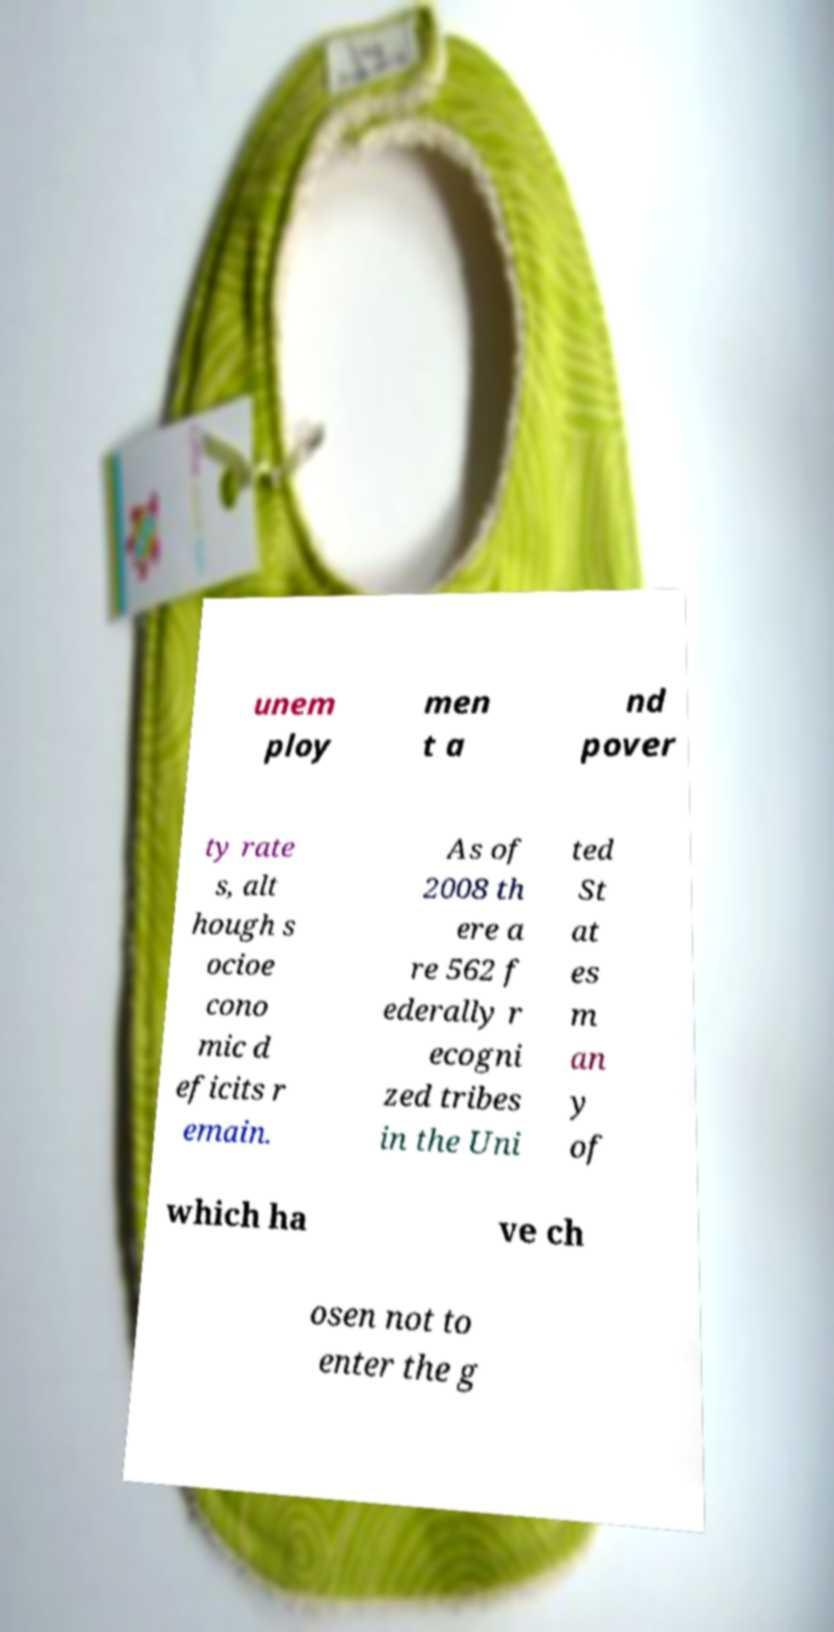Please read and relay the text visible in this image. What does it say? unem ploy men t a nd pover ty rate s, alt hough s ocioe cono mic d eficits r emain. As of 2008 th ere a re 562 f ederally r ecogni zed tribes in the Uni ted St at es m an y of which ha ve ch osen not to enter the g 